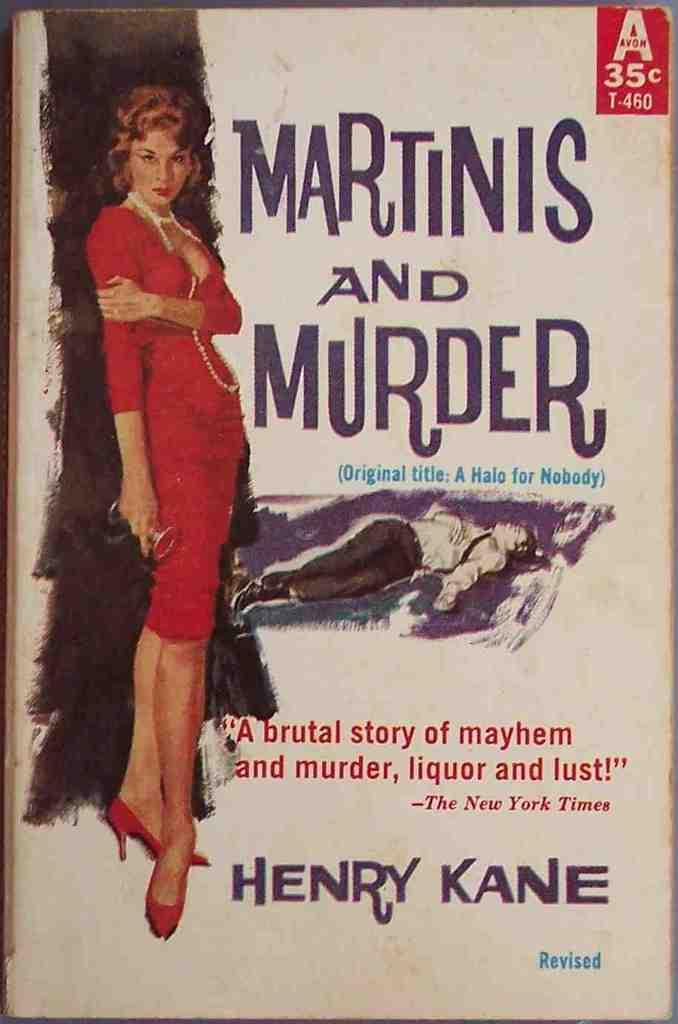<image>
Create a compact narrative representing the image presented. A book by Henry Kane shows a woman in red on the front. 